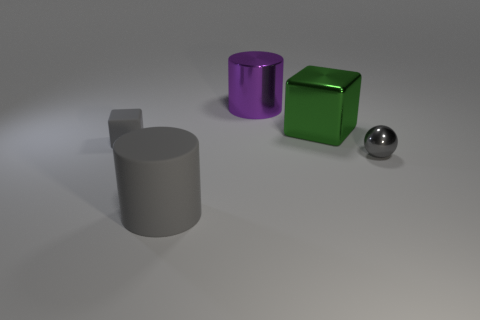There is a gray matte object behind the tiny metallic object; is its size the same as the gray thing right of the purple object?
Make the answer very short. Yes. There is a cube to the right of the large thing in front of the gray ball; what is its material?
Your answer should be very brief. Metal. What number of things are big objects in front of the small gray metallic sphere or gray metallic spheres?
Keep it short and to the point. 2. Are there the same number of green shiny cubes in front of the large matte thing and metal spheres that are to the right of the small ball?
Offer a very short reply. Yes. What is the material of the tiny object to the right of the large object that is in front of the cube on the left side of the big gray matte cylinder?
Provide a short and direct response. Metal. There is a object that is on the right side of the gray cylinder and in front of the large green cube; how big is it?
Provide a succinct answer. Small. Does the large gray matte object have the same shape as the purple thing?
Your answer should be very brief. Yes. What is the shape of the small thing that is the same material as the large purple object?
Make the answer very short. Sphere. How many tiny objects are brown blocks or green metal blocks?
Keep it short and to the point. 0. There is a cube in front of the large green metal cube; is there a big rubber cylinder in front of it?
Ensure brevity in your answer.  Yes. 